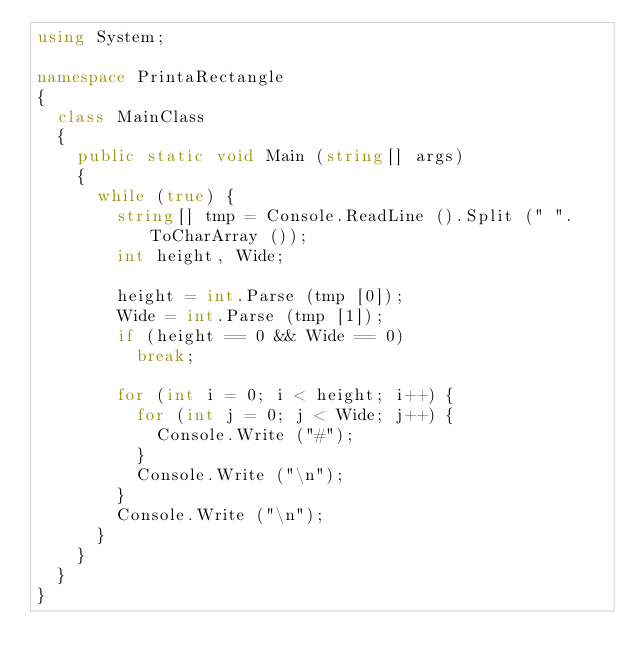Convert code to text. <code><loc_0><loc_0><loc_500><loc_500><_C#_>using System;

namespace PrintaRectangle
{
	class MainClass
	{
		public static void Main (string[] args)
		{
			while (true) {
				string[] tmp = Console.ReadLine ().Split (" ".ToCharArray ());
				int height, Wide;

				height = int.Parse (tmp [0]);
				Wide = int.Parse (tmp [1]);
				if (height == 0 && Wide == 0)
					break;

				for (int i = 0; i < height; i++) {
					for (int j = 0; j < Wide; j++) {
						Console.Write ("#");
					}
					Console.Write ("\n");
				}
				Console.Write ("\n");
			}
		}
	}
}</code> 